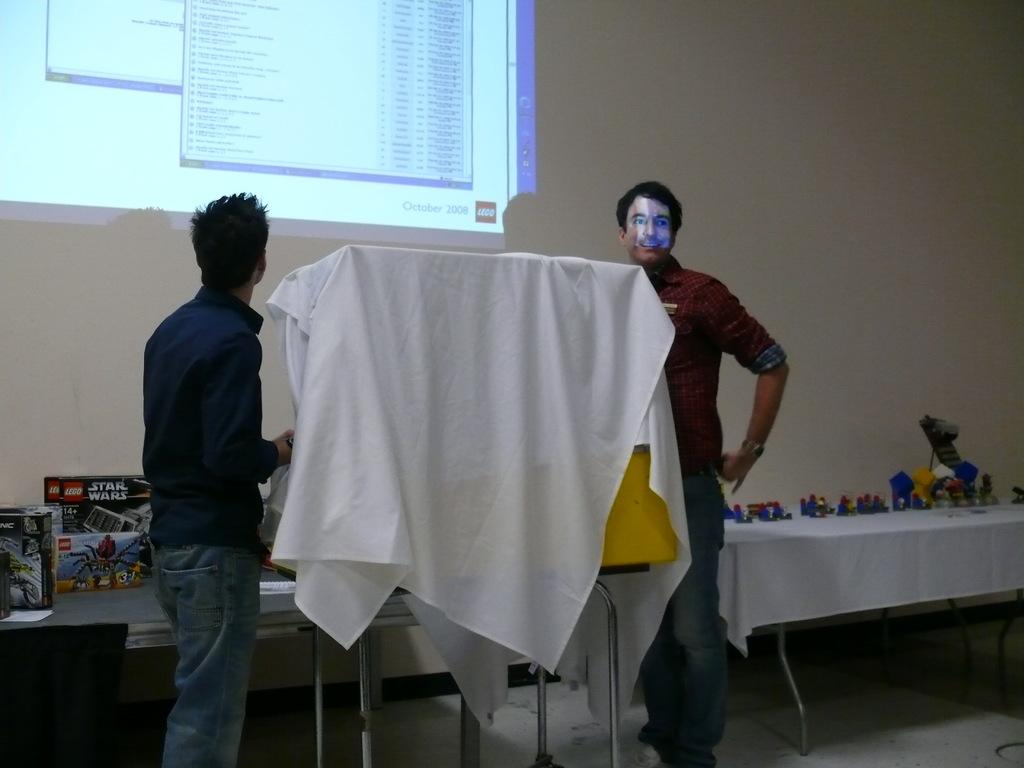How many people are present in the image? There are two people standing in the image. What is located in the front of the image? There is a board in the front of the image. What can be seen to the left of the image? There are objects to the left of the image. What is situated in the back of the image? There is a projector in the back of the image. What type of land can be seen in the image? There is no land visible in the image; it appears to be an indoor setting. What is the relationship between the two people and the objects to the left? The relationship between the two people and the objects to the left cannot be determined from the image alone. 